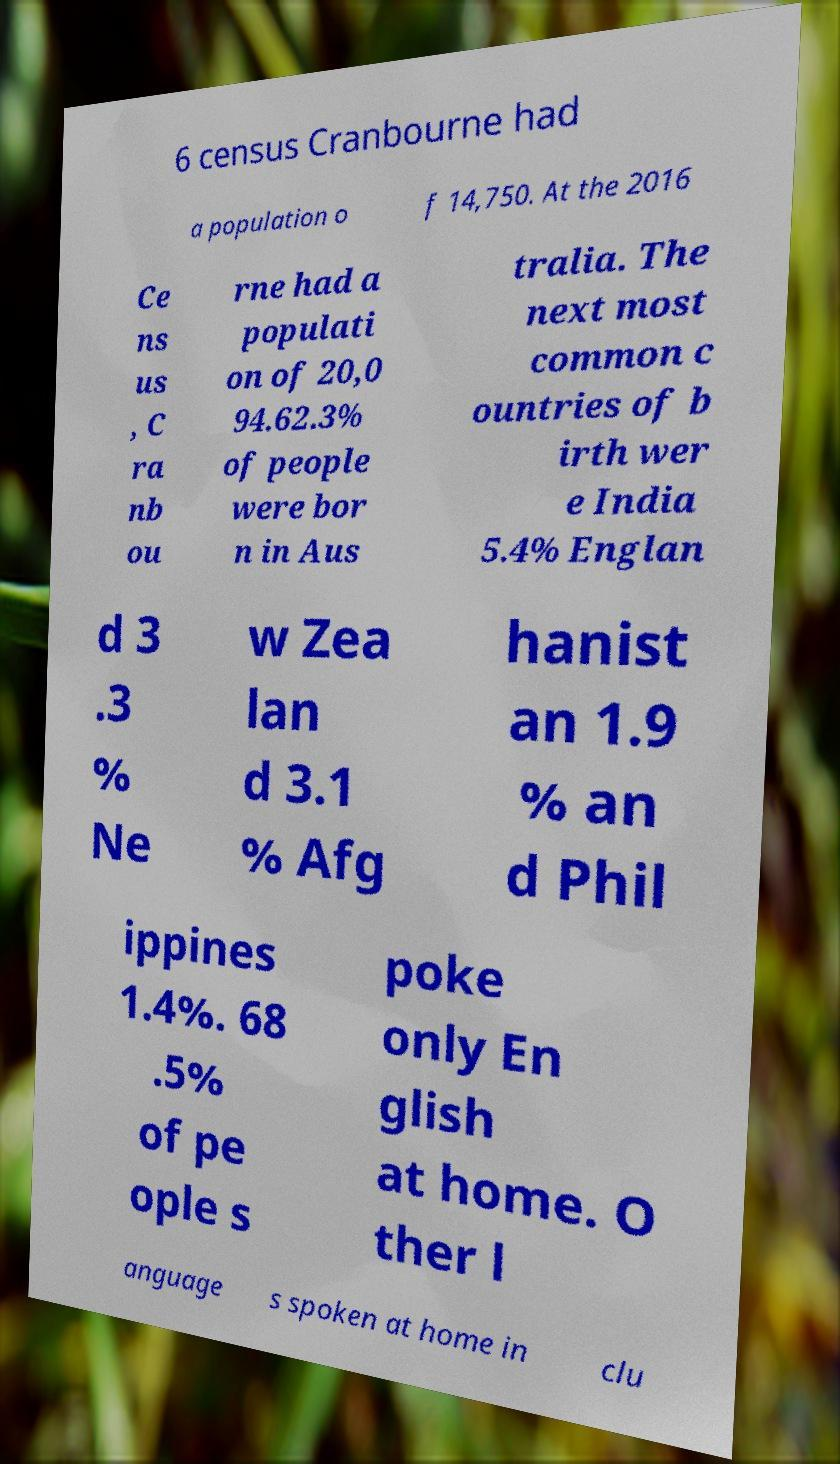What messages or text are displayed in this image? I need them in a readable, typed format. 6 census Cranbourne had a population o f 14,750. At the 2016 Ce ns us , C ra nb ou rne had a populati on of 20,0 94.62.3% of people were bor n in Aus tralia. The next most common c ountries of b irth wer e India 5.4% Englan d 3 .3 % Ne w Zea lan d 3.1 % Afg hanist an 1.9 % an d Phil ippines 1.4%. 68 .5% of pe ople s poke only En glish at home. O ther l anguage s spoken at home in clu 